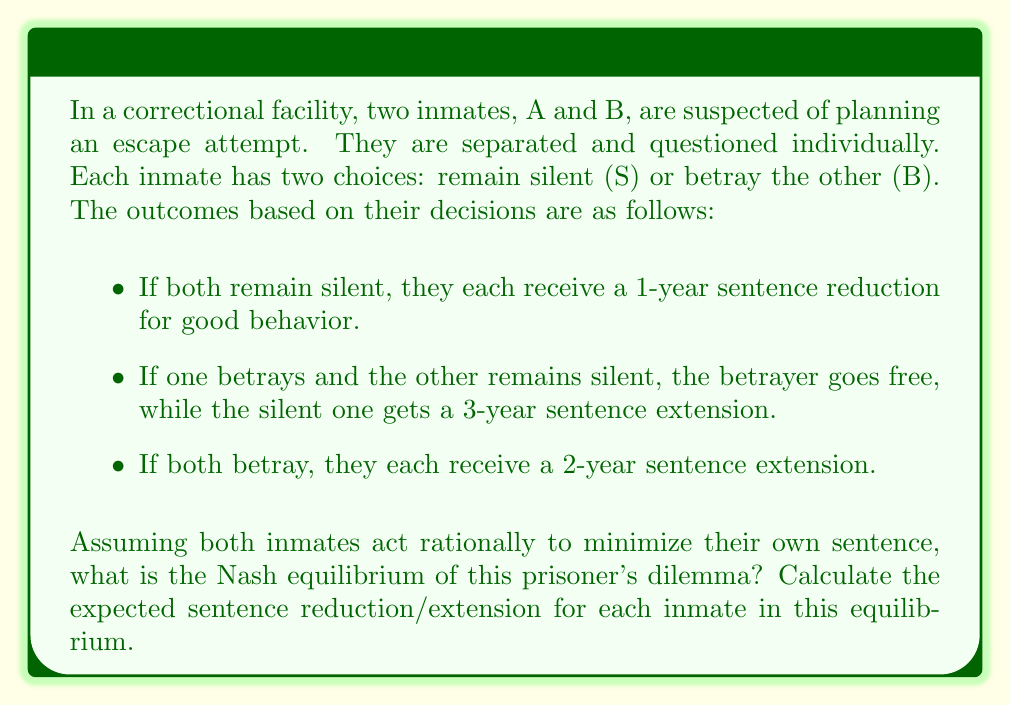What is the answer to this math problem? To solve this prisoner's dilemma, we need to analyze the payoff matrix and determine the Nash equilibrium. Let's start by creating the payoff matrix:

$$
\begin{array}{c|c|c}
A \backslash B & \text{Silent (S)} & \text{Betray (B)} \\
\hline
\text{Silent (S)} & (-1, -1) & (3, 0) \\
\hline
\text{Betray (B)} & (0, 3) & (2, 2)
\end{array}
$$

In this matrix, positive values represent sentence extensions, and negative values represent sentence reductions.

To find the Nash equilibrium, we need to determine the best response for each inmate given the other's strategy:

1. If B chooses S:
   - A's best response is B (0 < 3)
2. If B chooses B:
   - A's best response is B (2 < 3)
3. If A chooses S:
   - B's best response is B (0 < 3)
4. If A chooses B:
   - B's best response is B (2 < 3)

We can see that regardless of what the other inmate does, the best strategy for each inmate is to betray (B). This makes (B, B) the Nash equilibrium of this game.

In the Nash equilibrium (B, B), both inmates betray each other, resulting in a 2-year sentence extension for each inmate.

It's worth noting that this outcome is not Pareto optimal, as both inmates would be better off if they both remained silent (S, S). However, the incentive to betray and potentially go free leads to the suboptimal Nash equilibrium.
Answer: The Nash equilibrium is (Betray, Betray), with each inmate receiving a 2-year sentence extension. 